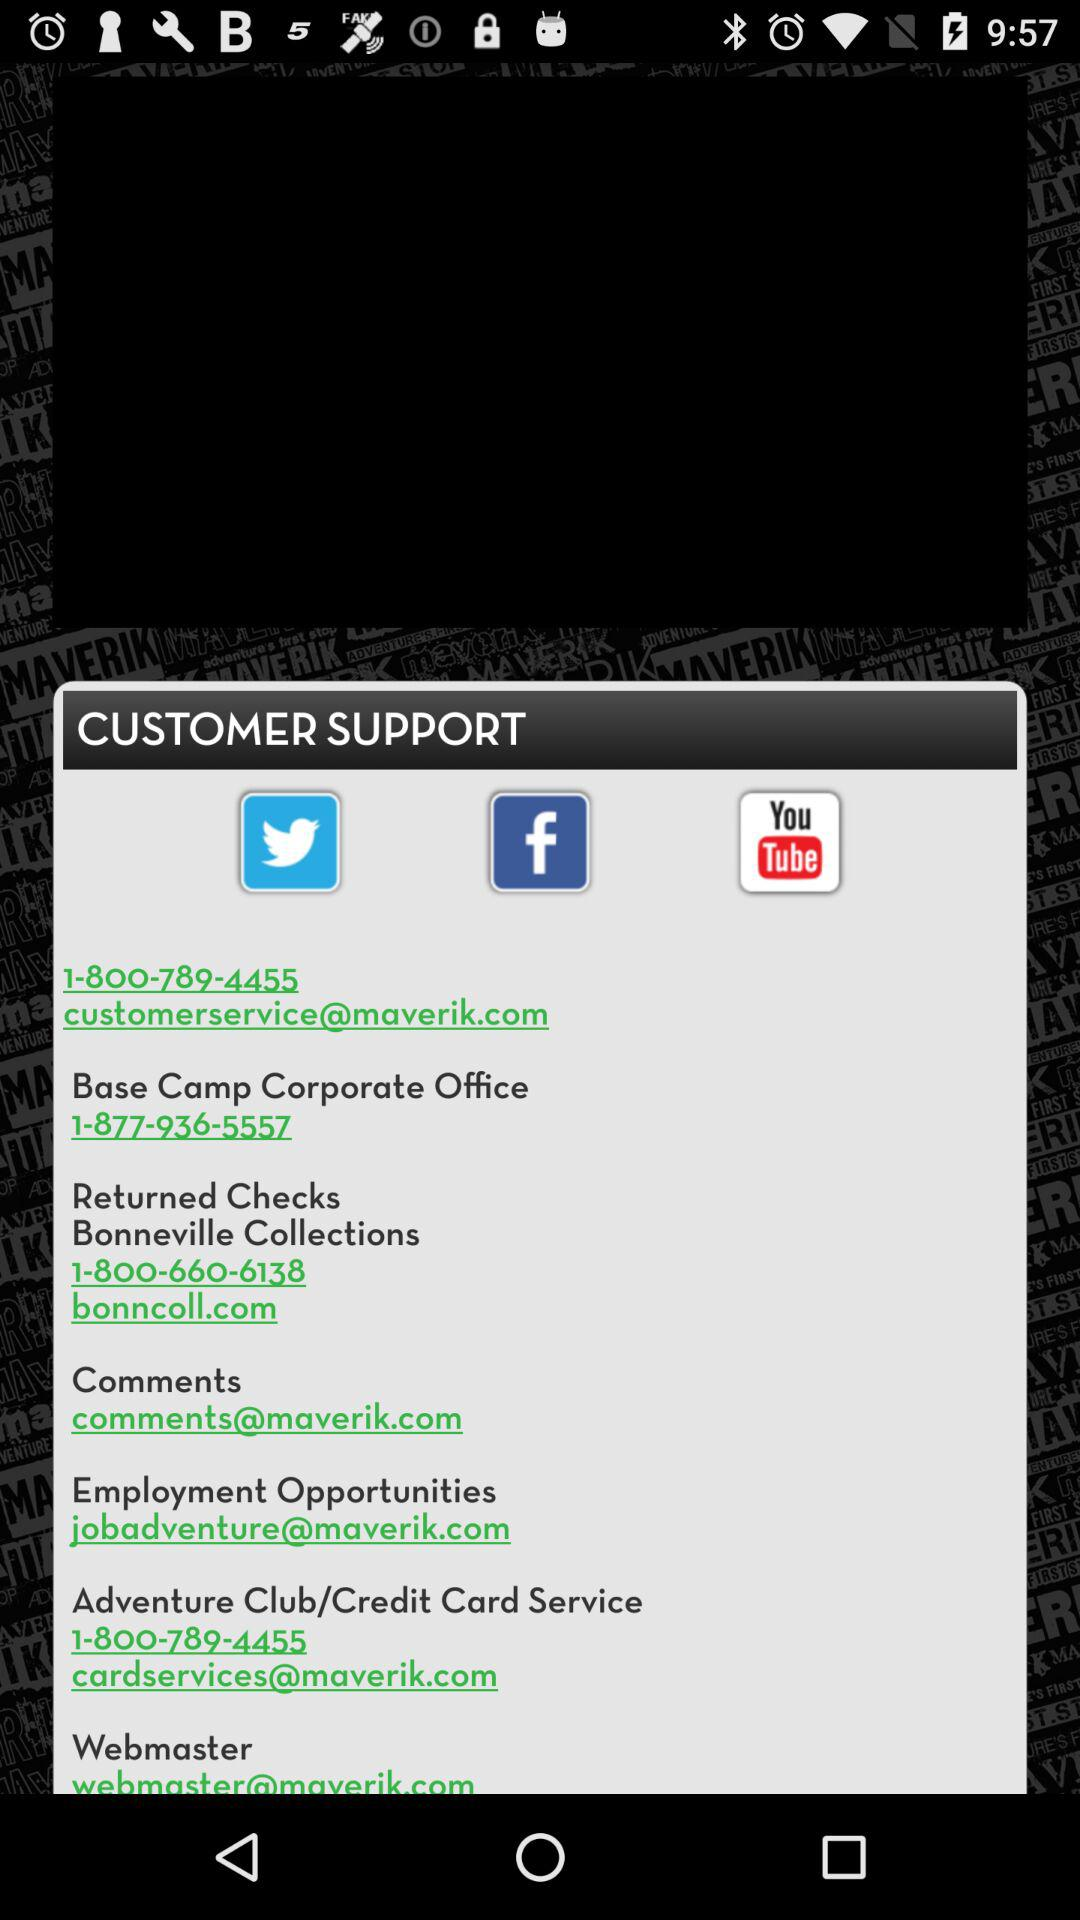What is the contact number for the Base Camp Corporate Office? The contact number for the Base Camp Corporate Office is 1-877-936-5557. 